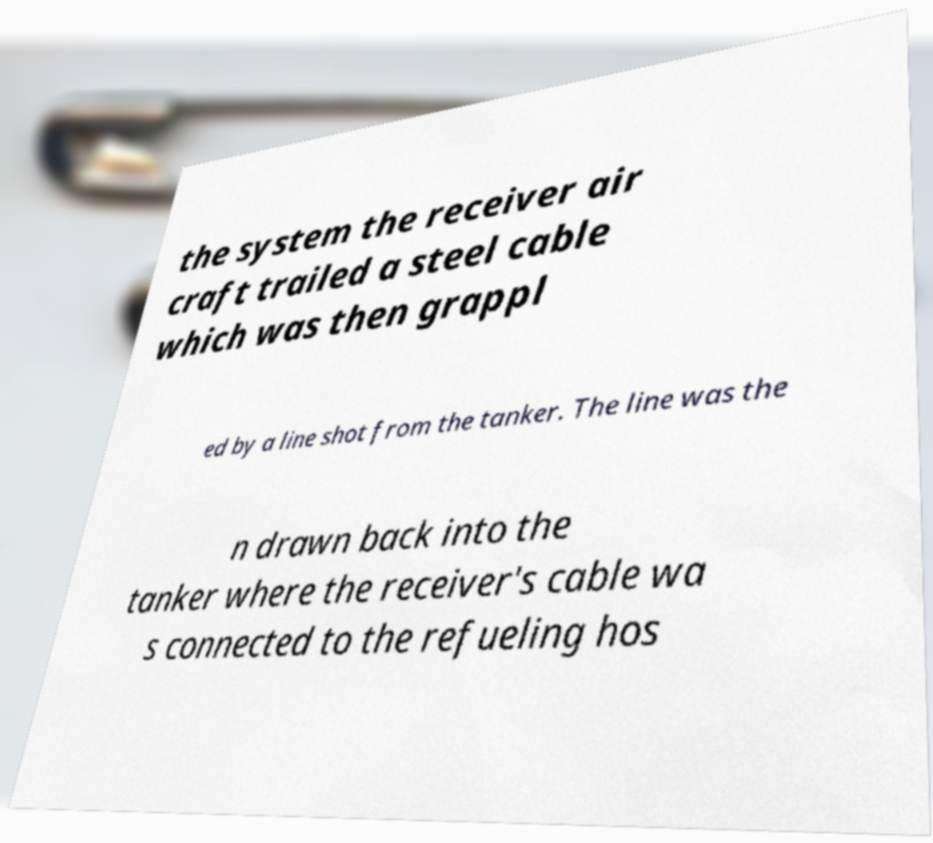Please identify and transcribe the text found in this image. the system the receiver air craft trailed a steel cable which was then grappl ed by a line shot from the tanker. The line was the n drawn back into the tanker where the receiver's cable wa s connected to the refueling hos 